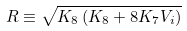<formula> <loc_0><loc_0><loc_500><loc_500>R \equiv \sqrt { K _ { 8 } \left ( K _ { 8 } + 8 K _ { 7 } V _ { i } \right ) }</formula> 